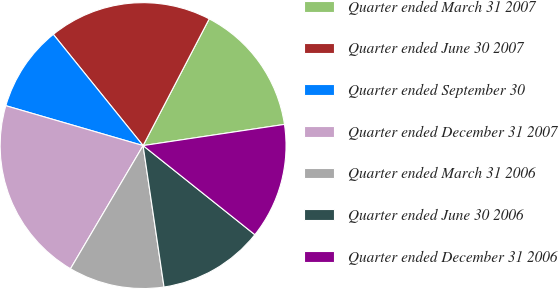<chart> <loc_0><loc_0><loc_500><loc_500><pie_chart><fcel>Quarter ended March 31 2007<fcel>Quarter ended June 30 2007<fcel>Quarter ended September 30<fcel>Quarter ended December 31 2007<fcel>Quarter ended March 31 2006<fcel>Quarter ended June 30 2006<fcel>Quarter ended December 31 2006<nl><fcel>14.98%<fcel>18.46%<fcel>9.69%<fcel>21.02%<fcel>10.82%<fcel>11.95%<fcel>13.08%<nl></chart> 